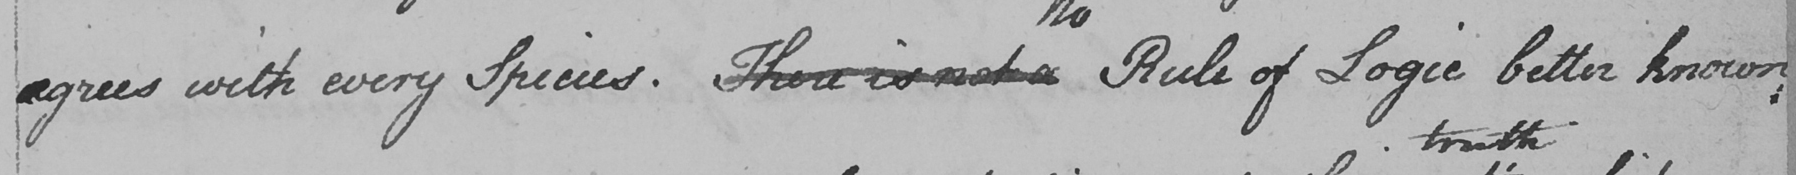Can you read and transcribe this handwriting? agrees with every Species . There is not a Rule of Logic better known 